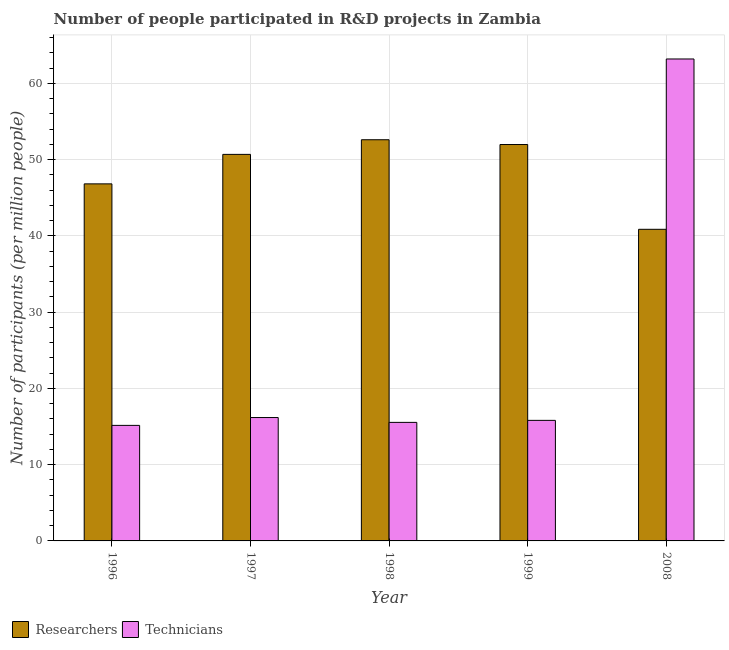How many groups of bars are there?
Provide a succinct answer. 5. Are the number of bars per tick equal to the number of legend labels?
Provide a succinct answer. Yes. Are the number of bars on each tick of the X-axis equal?
Make the answer very short. Yes. How many bars are there on the 4th tick from the left?
Your response must be concise. 2. How many bars are there on the 5th tick from the right?
Ensure brevity in your answer.  2. What is the label of the 5th group of bars from the left?
Your answer should be compact. 2008. In how many cases, is the number of bars for a given year not equal to the number of legend labels?
Your answer should be compact. 0. What is the number of technicians in 1997?
Make the answer very short. 16.18. Across all years, what is the maximum number of technicians?
Make the answer very short. 63.21. Across all years, what is the minimum number of technicians?
Offer a terse response. 15.15. What is the total number of researchers in the graph?
Provide a short and direct response. 243.01. What is the difference between the number of researchers in 1997 and that in 2008?
Make the answer very short. 9.83. What is the difference between the number of technicians in 1996 and the number of researchers in 1999?
Your answer should be very brief. -0.66. What is the average number of researchers per year?
Provide a succinct answer. 48.6. In the year 2008, what is the difference between the number of technicians and number of researchers?
Ensure brevity in your answer.  0. What is the ratio of the number of technicians in 1996 to that in 1999?
Keep it short and to the point. 0.96. What is the difference between the highest and the second highest number of researchers?
Your answer should be compact. 0.63. What is the difference between the highest and the lowest number of technicians?
Your response must be concise. 48.06. In how many years, is the number of researchers greater than the average number of researchers taken over all years?
Ensure brevity in your answer.  3. Is the sum of the number of researchers in 1997 and 2008 greater than the maximum number of technicians across all years?
Offer a very short reply. Yes. What does the 1st bar from the left in 2008 represents?
Your answer should be compact. Researchers. What does the 2nd bar from the right in 1999 represents?
Offer a very short reply. Researchers. What is the difference between two consecutive major ticks on the Y-axis?
Your answer should be compact. 10. How are the legend labels stacked?
Provide a short and direct response. Horizontal. What is the title of the graph?
Your response must be concise. Number of people participated in R&D projects in Zambia. Does "Mobile cellular" appear as one of the legend labels in the graph?
Keep it short and to the point. No. What is the label or title of the Y-axis?
Keep it short and to the point. Number of participants (per million people). What is the Number of participants (per million people) of Researchers in 1996?
Keep it short and to the point. 46.83. What is the Number of participants (per million people) of Technicians in 1996?
Your answer should be compact. 15.15. What is the Number of participants (per million people) in Researchers in 1997?
Your answer should be very brief. 50.7. What is the Number of participants (per million people) in Technicians in 1997?
Your answer should be very brief. 16.18. What is the Number of participants (per million people) of Researchers in 1998?
Your answer should be very brief. 52.62. What is the Number of participants (per million people) of Technicians in 1998?
Provide a succinct answer. 15.55. What is the Number of participants (per million people) of Researchers in 1999?
Keep it short and to the point. 51.99. What is the Number of participants (per million people) in Technicians in 1999?
Your response must be concise. 15.81. What is the Number of participants (per million people) of Researchers in 2008?
Keep it short and to the point. 40.87. What is the Number of participants (per million people) of Technicians in 2008?
Offer a terse response. 63.21. Across all years, what is the maximum Number of participants (per million people) of Researchers?
Provide a succinct answer. 52.62. Across all years, what is the maximum Number of participants (per million people) in Technicians?
Provide a succinct answer. 63.21. Across all years, what is the minimum Number of participants (per million people) of Researchers?
Offer a terse response. 40.87. Across all years, what is the minimum Number of participants (per million people) of Technicians?
Offer a very short reply. 15.15. What is the total Number of participants (per million people) in Researchers in the graph?
Your answer should be compact. 243.01. What is the total Number of participants (per million people) of Technicians in the graph?
Give a very brief answer. 125.91. What is the difference between the Number of participants (per million people) in Researchers in 1996 and that in 1997?
Offer a terse response. -3.87. What is the difference between the Number of participants (per million people) in Technicians in 1996 and that in 1997?
Make the answer very short. -1.03. What is the difference between the Number of participants (per million people) of Researchers in 1996 and that in 1998?
Your answer should be compact. -5.79. What is the difference between the Number of participants (per million people) in Technicians in 1996 and that in 1998?
Offer a terse response. -0.39. What is the difference between the Number of participants (per million people) of Researchers in 1996 and that in 1999?
Provide a short and direct response. -5.16. What is the difference between the Number of participants (per million people) in Technicians in 1996 and that in 1999?
Make the answer very short. -0.66. What is the difference between the Number of participants (per million people) of Researchers in 1996 and that in 2008?
Offer a terse response. 5.96. What is the difference between the Number of participants (per million people) in Technicians in 1996 and that in 2008?
Offer a very short reply. -48.06. What is the difference between the Number of participants (per million people) of Researchers in 1997 and that in 1998?
Offer a terse response. -1.92. What is the difference between the Number of participants (per million people) in Technicians in 1997 and that in 1998?
Keep it short and to the point. 0.64. What is the difference between the Number of participants (per million people) in Researchers in 1997 and that in 1999?
Offer a very short reply. -1.29. What is the difference between the Number of participants (per million people) in Technicians in 1997 and that in 1999?
Give a very brief answer. 0.37. What is the difference between the Number of participants (per million people) in Researchers in 1997 and that in 2008?
Make the answer very short. 9.83. What is the difference between the Number of participants (per million people) of Technicians in 1997 and that in 2008?
Make the answer very short. -47.03. What is the difference between the Number of participants (per million people) in Researchers in 1998 and that in 1999?
Make the answer very short. 0.63. What is the difference between the Number of participants (per million people) in Technicians in 1998 and that in 1999?
Your answer should be very brief. -0.26. What is the difference between the Number of participants (per million people) in Researchers in 1998 and that in 2008?
Offer a terse response. 11.75. What is the difference between the Number of participants (per million people) in Technicians in 1998 and that in 2008?
Provide a short and direct response. -47.67. What is the difference between the Number of participants (per million people) in Researchers in 1999 and that in 2008?
Give a very brief answer. 11.12. What is the difference between the Number of participants (per million people) of Technicians in 1999 and that in 2008?
Provide a succinct answer. -47.4. What is the difference between the Number of participants (per million people) of Researchers in 1996 and the Number of participants (per million people) of Technicians in 1997?
Give a very brief answer. 30.65. What is the difference between the Number of participants (per million people) of Researchers in 1996 and the Number of participants (per million people) of Technicians in 1998?
Provide a succinct answer. 31.28. What is the difference between the Number of participants (per million people) in Researchers in 1996 and the Number of participants (per million people) in Technicians in 1999?
Provide a short and direct response. 31.02. What is the difference between the Number of participants (per million people) in Researchers in 1996 and the Number of participants (per million people) in Technicians in 2008?
Your answer should be compact. -16.38. What is the difference between the Number of participants (per million people) in Researchers in 1997 and the Number of participants (per million people) in Technicians in 1998?
Your response must be concise. 35.15. What is the difference between the Number of participants (per million people) of Researchers in 1997 and the Number of participants (per million people) of Technicians in 1999?
Keep it short and to the point. 34.89. What is the difference between the Number of participants (per million people) of Researchers in 1997 and the Number of participants (per million people) of Technicians in 2008?
Your answer should be very brief. -12.51. What is the difference between the Number of participants (per million people) of Researchers in 1998 and the Number of participants (per million people) of Technicians in 1999?
Your response must be concise. 36.81. What is the difference between the Number of participants (per million people) in Researchers in 1998 and the Number of participants (per million people) in Technicians in 2008?
Keep it short and to the point. -10.59. What is the difference between the Number of participants (per million people) in Researchers in 1999 and the Number of participants (per million people) in Technicians in 2008?
Provide a short and direct response. -11.22. What is the average Number of participants (per million people) of Researchers per year?
Keep it short and to the point. 48.6. What is the average Number of participants (per million people) of Technicians per year?
Your response must be concise. 25.18. In the year 1996, what is the difference between the Number of participants (per million people) of Researchers and Number of participants (per million people) of Technicians?
Give a very brief answer. 31.68. In the year 1997, what is the difference between the Number of participants (per million people) in Researchers and Number of participants (per million people) in Technicians?
Provide a succinct answer. 34.52. In the year 1998, what is the difference between the Number of participants (per million people) in Researchers and Number of participants (per million people) in Technicians?
Your answer should be very brief. 37.07. In the year 1999, what is the difference between the Number of participants (per million people) of Researchers and Number of participants (per million people) of Technicians?
Offer a very short reply. 36.18. In the year 2008, what is the difference between the Number of participants (per million people) of Researchers and Number of participants (per million people) of Technicians?
Your answer should be compact. -22.34. What is the ratio of the Number of participants (per million people) in Researchers in 1996 to that in 1997?
Your answer should be compact. 0.92. What is the ratio of the Number of participants (per million people) in Technicians in 1996 to that in 1997?
Ensure brevity in your answer.  0.94. What is the ratio of the Number of participants (per million people) of Researchers in 1996 to that in 1998?
Offer a very short reply. 0.89. What is the ratio of the Number of participants (per million people) in Technicians in 1996 to that in 1998?
Give a very brief answer. 0.97. What is the ratio of the Number of participants (per million people) in Researchers in 1996 to that in 1999?
Offer a very short reply. 0.9. What is the ratio of the Number of participants (per million people) of Technicians in 1996 to that in 1999?
Provide a short and direct response. 0.96. What is the ratio of the Number of participants (per million people) in Researchers in 1996 to that in 2008?
Ensure brevity in your answer.  1.15. What is the ratio of the Number of participants (per million people) of Technicians in 1996 to that in 2008?
Your answer should be compact. 0.24. What is the ratio of the Number of participants (per million people) in Researchers in 1997 to that in 1998?
Provide a short and direct response. 0.96. What is the ratio of the Number of participants (per million people) of Technicians in 1997 to that in 1998?
Provide a short and direct response. 1.04. What is the ratio of the Number of participants (per million people) of Researchers in 1997 to that in 1999?
Ensure brevity in your answer.  0.98. What is the ratio of the Number of participants (per million people) in Technicians in 1997 to that in 1999?
Give a very brief answer. 1.02. What is the ratio of the Number of participants (per million people) in Researchers in 1997 to that in 2008?
Provide a succinct answer. 1.24. What is the ratio of the Number of participants (per million people) of Technicians in 1997 to that in 2008?
Your answer should be very brief. 0.26. What is the ratio of the Number of participants (per million people) in Researchers in 1998 to that in 1999?
Provide a succinct answer. 1.01. What is the ratio of the Number of participants (per million people) of Technicians in 1998 to that in 1999?
Offer a very short reply. 0.98. What is the ratio of the Number of participants (per million people) of Researchers in 1998 to that in 2008?
Your answer should be compact. 1.29. What is the ratio of the Number of participants (per million people) of Technicians in 1998 to that in 2008?
Your answer should be compact. 0.25. What is the ratio of the Number of participants (per million people) of Researchers in 1999 to that in 2008?
Provide a short and direct response. 1.27. What is the ratio of the Number of participants (per million people) of Technicians in 1999 to that in 2008?
Keep it short and to the point. 0.25. What is the difference between the highest and the second highest Number of participants (per million people) in Researchers?
Provide a short and direct response. 0.63. What is the difference between the highest and the second highest Number of participants (per million people) of Technicians?
Your response must be concise. 47.03. What is the difference between the highest and the lowest Number of participants (per million people) in Researchers?
Offer a terse response. 11.75. What is the difference between the highest and the lowest Number of participants (per million people) of Technicians?
Offer a terse response. 48.06. 